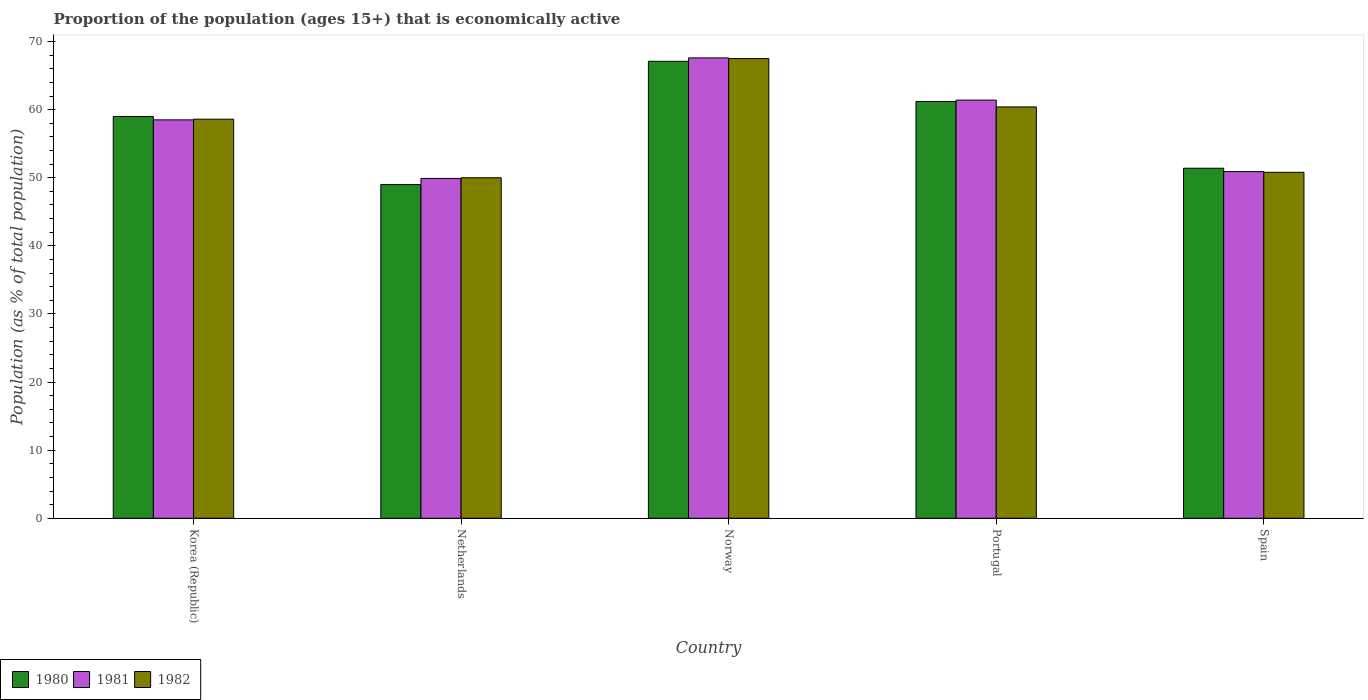Are the number of bars per tick equal to the number of legend labels?
Make the answer very short. Yes. How many bars are there on the 2nd tick from the right?
Provide a succinct answer. 3. What is the label of the 4th group of bars from the left?
Make the answer very short. Portugal. Across all countries, what is the maximum proportion of the population that is economically active in 1981?
Ensure brevity in your answer.  67.6. Across all countries, what is the minimum proportion of the population that is economically active in 1980?
Your response must be concise. 49. In which country was the proportion of the population that is economically active in 1982 maximum?
Provide a succinct answer. Norway. What is the total proportion of the population that is economically active in 1981 in the graph?
Your answer should be compact. 288.3. What is the difference between the proportion of the population that is economically active in 1980 in Netherlands and that in Norway?
Provide a succinct answer. -18.1. What is the difference between the proportion of the population that is economically active in 1982 in Netherlands and the proportion of the population that is economically active in 1980 in Spain?
Ensure brevity in your answer.  -1.4. What is the average proportion of the population that is economically active in 1982 per country?
Your answer should be compact. 57.46. What is the difference between the proportion of the population that is economically active of/in 1982 and proportion of the population that is economically active of/in 1981 in Korea (Republic)?
Offer a terse response. 0.1. What is the ratio of the proportion of the population that is economically active in 1982 in Norway to that in Spain?
Ensure brevity in your answer.  1.33. Is the proportion of the population that is economically active in 1982 in Netherlands less than that in Spain?
Make the answer very short. Yes. Is the difference between the proportion of the population that is economically active in 1982 in Norway and Portugal greater than the difference between the proportion of the population that is economically active in 1981 in Norway and Portugal?
Provide a short and direct response. Yes. What is the difference between the highest and the second highest proportion of the population that is economically active in 1981?
Your answer should be very brief. -9.1. In how many countries, is the proportion of the population that is economically active in 1982 greater than the average proportion of the population that is economically active in 1982 taken over all countries?
Offer a very short reply. 3. Is the sum of the proportion of the population that is economically active in 1980 in Netherlands and Norway greater than the maximum proportion of the population that is economically active in 1981 across all countries?
Ensure brevity in your answer.  Yes. What does the 2nd bar from the left in Portugal represents?
Keep it short and to the point. 1981. What does the 1st bar from the right in Norway represents?
Provide a succinct answer. 1982. Is it the case that in every country, the sum of the proportion of the population that is economically active in 1982 and proportion of the population that is economically active in 1980 is greater than the proportion of the population that is economically active in 1981?
Provide a short and direct response. Yes. Are all the bars in the graph horizontal?
Give a very brief answer. No. What is the difference between two consecutive major ticks on the Y-axis?
Your answer should be compact. 10. Are the values on the major ticks of Y-axis written in scientific E-notation?
Your answer should be compact. No. Does the graph contain grids?
Provide a succinct answer. No. What is the title of the graph?
Keep it short and to the point. Proportion of the population (ages 15+) that is economically active. Does "1984" appear as one of the legend labels in the graph?
Ensure brevity in your answer.  No. What is the label or title of the X-axis?
Keep it short and to the point. Country. What is the label or title of the Y-axis?
Your answer should be very brief. Population (as % of total population). What is the Population (as % of total population) in 1980 in Korea (Republic)?
Offer a very short reply. 59. What is the Population (as % of total population) in 1981 in Korea (Republic)?
Give a very brief answer. 58.5. What is the Population (as % of total population) in 1982 in Korea (Republic)?
Offer a terse response. 58.6. What is the Population (as % of total population) of 1981 in Netherlands?
Your response must be concise. 49.9. What is the Population (as % of total population) of 1980 in Norway?
Give a very brief answer. 67.1. What is the Population (as % of total population) in 1981 in Norway?
Make the answer very short. 67.6. What is the Population (as % of total population) in 1982 in Norway?
Make the answer very short. 67.5. What is the Population (as % of total population) of 1980 in Portugal?
Your answer should be very brief. 61.2. What is the Population (as % of total population) in 1981 in Portugal?
Give a very brief answer. 61.4. What is the Population (as % of total population) of 1982 in Portugal?
Your answer should be very brief. 60.4. What is the Population (as % of total population) of 1980 in Spain?
Keep it short and to the point. 51.4. What is the Population (as % of total population) in 1981 in Spain?
Your answer should be very brief. 50.9. What is the Population (as % of total population) in 1982 in Spain?
Your answer should be compact. 50.8. Across all countries, what is the maximum Population (as % of total population) of 1980?
Ensure brevity in your answer.  67.1. Across all countries, what is the maximum Population (as % of total population) of 1981?
Keep it short and to the point. 67.6. Across all countries, what is the maximum Population (as % of total population) in 1982?
Your response must be concise. 67.5. Across all countries, what is the minimum Population (as % of total population) of 1981?
Make the answer very short. 49.9. Across all countries, what is the minimum Population (as % of total population) in 1982?
Your answer should be very brief. 50. What is the total Population (as % of total population) in 1980 in the graph?
Ensure brevity in your answer.  287.7. What is the total Population (as % of total population) in 1981 in the graph?
Keep it short and to the point. 288.3. What is the total Population (as % of total population) of 1982 in the graph?
Your response must be concise. 287.3. What is the difference between the Population (as % of total population) of 1980 in Korea (Republic) and that in Netherlands?
Your answer should be compact. 10. What is the difference between the Population (as % of total population) of 1981 in Korea (Republic) and that in Netherlands?
Your answer should be very brief. 8.6. What is the difference between the Population (as % of total population) in 1982 in Korea (Republic) and that in Netherlands?
Make the answer very short. 8.6. What is the difference between the Population (as % of total population) in 1980 in Korea (Republic) and that in Norway?
Provide a succinct answer. -8.1. What is the difference between the Population (as % of total population) in 1982 in Korea (Republic) and that in Norway?
Your response must be concise. -8.9. What is the difference between the Population (as % of total population) in 1981 in Korea (Republic) and that in Portugal?
Provide a succinct answer. -2.9. What is the difference between the Population (as % of total population) in 1982 in Korea (Republic) and that in Portugal?
Ensure brevity in your answer.  -1.8. What is the difference between the Population (as % of total population) in 1981 in Korea (Republic) and that in Spain?
Offer a terse response. 7.6. What is the difference between the Population (as % of total population) in 1980 in Netherlands and that in Norway?
Keep it short and to the point. -18.1. What is the difference between the Population (as % of total population) in 1981 in Netherlands and that in Norway?
Make the answer very short. -17.7. What is the difference between the Population (as % of total population) in 1982 in Netherlands and that in Norway?
Provide a short and direct response. -17.5. What is the difference between the Population (as % of total population) of 1982 in Netherlands and that in Portugal?
Give a very brief answer. -10.4. What is the difference between the Population (as % of total population) in 1981 in Netherlands and that in Spain?
Your response must be concise. -1. What is the difference between the Population (as % of total population) of 1980 in Norway and that in Portugal?
Your response must be concise. 5.9. What is the difference between the Population (as % of total population) in 1980 in Norway and that in Spain?
Keep it short and to the point. 15.7. What is the difference between the Population (as % of total population) in 1981 in Portugal and that in Spain?
Offer a terse response. 10.5. What is the difference between the Population (as % of total population) of 1980 in Korea (Republic) and the Population (as % of total population) of 1981 in Netherlands?
Your response must be concise. 9.1. What is the difference between the Population (as % of total population) of 1980 in Korea (Republic) and the Population (as % of total population) of 1982 in Netherlands?
Provide a short and direct response. 9. What is the difference between the Population (as % of total population) in 1980 in Korea (Republic) and the Population (as % of total population) in 1981 in Norway?
Give a very brief answer. -8.6. What is the difference between the Population (as % of total population) in 1980 in Korea (Republic) and the Population (as % of total population) in 1982 in Norway?
Make the answer very short. -8.5. What is the difference between the Population (as % of total population) in 1981 in Korea (Republic) and the Population (as % of total population) in 1982 in Norway?
Give a very brief answer. -9. What is the difference between the Population (as % of total population) of 1980 in Korea (Republic) and the Population (as % of total population) of 1981 in Portugal?
Keep it short and to the point. -2.4. What is the difference between the Population (as % of total population) in 1980 in Korea (Republic) and the Population (as % of total population) in 1982 in Portugal?
Keep it short and to the point. -1.4. What is the difference between the Population (as % of total population) in 1981 in Korea (Republic) and the Population (as % of total population) in 1982 in Portugal?
Offer a terse response. -1.9. What is the difference between the Population (as % of total population) in 1980 in Netherlands and the Population (as % of total population) in 1981 in Norway?
Make the answer very short. -18.6. What is the difference between the Population (as % of total population) of 1980 in Netherlands and the Population (as % of total population) of 1982 in Norway?
Provide a succinct answer. -18.5. What is the difference between the Population (as % of total population) of 1981 in Netherlands and the Population (as % of total population) of 1982 in Norway?
Provide a short and direct response. -17.6. What is the difference between the Population (as % of total population) in 1980 in Netherlands and the Population (as % of total population) in 1981 in Portugal?
Keep it short and to the point. -12.4. What is the difference between the Population (as % of total population) of 1980 in Netherlands and the Population (as % of total population) of 1982 in Portugal?
Provide a succinct answer. -11.4. What is the difference between the Population (as % of total population) of 1980 in Netherlands and the Population (as % of total population) of 1981 in Spain?
Provide a short and direct response. -1.9. What is the difference between the Population (as % of total population) of 1980 in Norway and the Population (as % of total population) of 1982 in Portugal?
Your answer should be very brief. 6.7. What is the difference between the Population (as % of total population) in 1980 in Norway and the Population (as % of total population) in 1981 in Spain?
Offer a very short reply. 16.2. What is the difference between the Population (as % of total population) of 1980 in Norway and the Population (as % of total population) of 1982 in Spain?
Provide a succinct answer. 16.3. What is the difference between the Population (as % of total population) in 1981 in Norway and the Population (as % of total population) in 1982 in Spain?
Offer a terse response. 16.8. What is the difference between the Population (as % of total population) of 1980 in Portugal and the Population (as % of total population) of 1981 in Spain?
Make the answer very short. 10.3. What is the difference between the Population (as % of total population) in 1980 in Portugal and the Population (as % of total population) in 1982 in Spain?
Provide a succinct answer. 10.4. What is the difference between the Population (as % of total population) of 1981 in Portugal and the Population (as % of total population) of 1982 in Spain?
Offer a very short reply. 10.6. What is the average Population (as % of total population) in 1980 per country?
Give a very brief answer. 57.54. What is the average Population (as % of total population) of 1981 per country?
Make the answer very short. 57.66. What is the average Population (as % of total population) in 1982 per country?
Provide a succinct answer. 57.46. What is the difference between the Population (as % of total population) of 1980 and Population (as % of total population) of 1981 in Korea (Republic)?
Your answer should be compact. 0.5. What is the difference between the Population (as % of total population) of 1980 and Population (as % of total population) of 1982 in Korea (Republic)?
Give a very brief answer. 0.4. What is the difference between the Population (as % of total population) in 1981 and Population (as % of total population) in 1982 in Korea (Republic)?
Your answer should be very brief. -0.1. What is the difference between the Population (as % of total population) in 1980 and Population (as % of total population) in 1981 in Netherlands?
Provide a succinct answer. -0.9. What is the difference between the Population (as % of total population) of 1980 and Population (as % of total population) of 1982 in Netherlands?
Your answer should be very brief. -1. What is the difference between the Population (as % of total population) of 1981 and Population (as % of total population) of 1982 in Netherlands?
Give a very brief answer. -0.1. What is the difference between the Population (as % of total population) of 1980 and Population (as % of total population) of 1981 in Norway?
Provide a short and direct response. -0.5. What is the difference between the Population (as % of total population) in 1980 and Population (as % of total population) in 1982 in Norway?
Your answer should be compact. -0.4. What is the difference between the Population (as % of total population) in 1981 and Population (as % of total population) in 1982 in Norway?
Provide a succinct answer. 0.1. What is the difference between the Population (as % of total population) in 1981 and Population (as % of total population) in 1982 in Spain?
Offer a very short reply. 0.1. What is the ratio of the Population (as % of total population) of 1980 in Korea (Republic) to that in Netherlands?
Offer a very short reply. 1.2. What is the ratio of the Population (as % of total population) in 1981 in Korea (Republic) to that in Netherlands?
Ensure brevity in your answer.  1.17. What is the ratio of the Population (as % of total population) of 1982 in Korea (Republic) to that in Netherlands?
Ensure brevity in your answer.  1.17. What is the ratio of the Population (as % of total population) in 1980 in Korea (Republic) to that in Norway?
Your answer should be compact. 0.88. What is the ratio of the Population (as % of total population) of 1981 in Korea (Republic) to that in Norway?
Give a very brief answer. 0.87. What is the ratio of the Population (as % of total population) of 1982 in Korea (Republic) to that in Norway?
Offer a very short reply. 0.87. What is the ratio of the Population (as % of total population) of 1980 in Korea (Republic) to that in Portugal?
Make the answer very short. 0.96. What is the ratio of the Population (as % of total population) in 1981 in Korea (Republic) to that in Portugal?
Your response must be concise. 0.95. What is the ratio of the Population (as % of total population) in 1982 in Korea (Republic) to that in Portugal?
Give a very brief answer. 0.97. What is the ratio of the Population (as % of total population) in 1980 in Korea (Republic) to that in Spain?
Your response must be concise. 1.15. What is the ratio of the Population (as % of total population) of 1981 in Korea (Republic) to that in Spain?
Provide a short and direct response. 1.15. What is the ratio of the Population (as % of total population) of 1982 in Korea (Republic) to that in Spain?
Keep it short and to the point. 1.15. What is the ratio of the Population (as % of total population) of 1980 in Netherlands to that in Norway?
Make the answer very short. 0.73. What is the ratio of the Population (as % of total population) of 1981 in Netherlands to that in Norway?
Offer a very short reply. 0.74. What is the ratio of the Population (as % of total population) of 1982 in Netherlands to that in Norway?
Offer a terse response. 0.74. What is the ratio of the Population (as % of total population) in 1980 in Netherlands to that in Portugal?
Provide a succinct answer. 0.8. What is the ratio of the Population (as % of total population) in 1981 in Netherlands to that in Portugal?
Keep it short and to the point. 0.81. What is the ratio of the Population (as % of total population) in 1982 in Netherlands to that in Portugal?
Provide a short and direct response. 0.83. What is the ratio of the Population (as % of total population) of 1980 in Netherlands to that in Spain?
Make the answer very short. 0.95. What is the ratio of the Population (as % of total population) of 1981 in Netherlands to that in Spain?
Give a very brief answer. 0.98. What is the ratio of the Population (as % of total population) of 1982 in Netherlands to that in Spain?
Provide a succinct answer. 0.98. What is the ratio of the Population (as % of total population) in 1980 in Norway to that in Portugal?
Your answer should be very brief. 1.1. What is the ratio of the Population (as % of total population) in 1981 in Norway to that in Portugal?
Ensure brevity in your answer.  1.1. What is the ratio of the Population (as % of total population) in 1982 in Norway to that in Portugal?
Make the answer very short. 1.12. What is the ratio of the Population (as % of total population) of 1980 in Norway to that in Spain?
Provide a succinct answer. 1.31. What is the ratio of the Population (as % of total population) in 1981 in Norway to that in Spain?
Offer a very short reply. 1.33. What is the ratio of the Population (as % of total population) of 1982 in Norway to that in Spain?
Offer a terse response. 1.33. What is the ratio of the Population (as % of total population) in 1980 in Portugal to that in Spain?
Your response must be concise. 1.19. What is the ratio of the Population (as % of total population) of 1981 in Portugal to that in Spain?
Give a very brief answer. 1.21. What is the ratio of the Population (as % of total population) of 1982 in Portugal to that in Spain?
Offer a terse response. 1.19. What is the difference between the highest and the lowest Population (as % of total population) in 1980?
Offer a terse response. 18.1. What is the difference between the highest and the lowest Population (as % of total population) in 1982?
Provide a short and direct response. 17.5. 